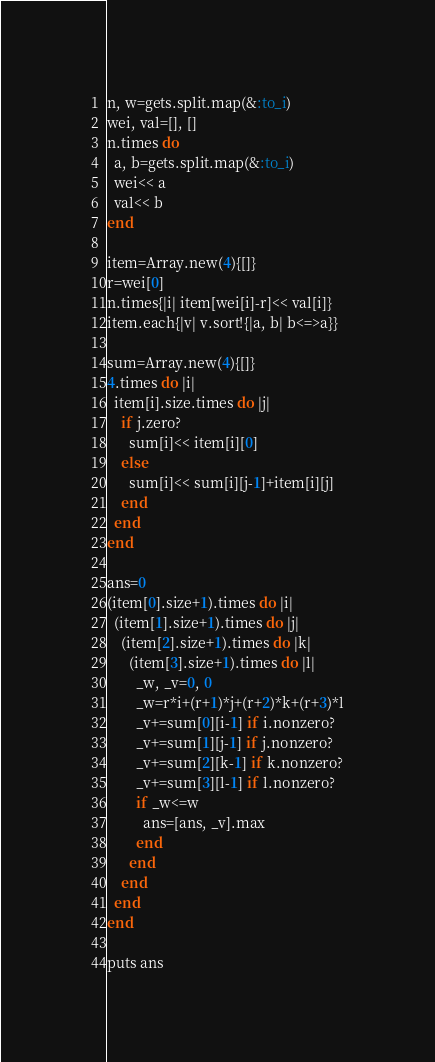Convert code to text. <code><loc_0><loc_0><loc_500><loc_500><_Ruby_>n, w=gets.split.map(&:to_i)
wei, val=[], []
n.times do
  a, b=gets.split.map(&:to_i)
  wei<< a
  val<< b
end

item=Array.new(4){[]}
r=wei[0]
n.times{|i| item[wei[i]-r]<< val[i]}
item.each{|v| v.sort!{|a, b| b<=>a}}

sum=Array.new(4){[]}
4.times do |i|
  item[i].size.times do |j|
    if j.zero?
      sum[i]<< item[i][0]
    else
      sum[i]<< sum[i][j-1]+item[i][j]
    end
  end
end

ans=0
(item[0].size+1).times do |i|
  (item[1].size+1).times do |j|
    (item[2].size+1).times do |k|
      (item[3].size+1).times do |l|
        _w, _v=0, 0
        _w=r*i+(r+1)*j+(r+2)*k+(r+3)*l
        _v+=sum[0][i-1] if i.nonzero?
        _v+=sum[1][j-1] if j.nonzero?
        _v+=sum[2][k-1] if k.nonzero?
        _v+=sum[3][l-1] if l.nonzero?
        if _w<=w
          ans=[ans, _v].max
        end
      end
    end
  end
end

puts ans
</code> 